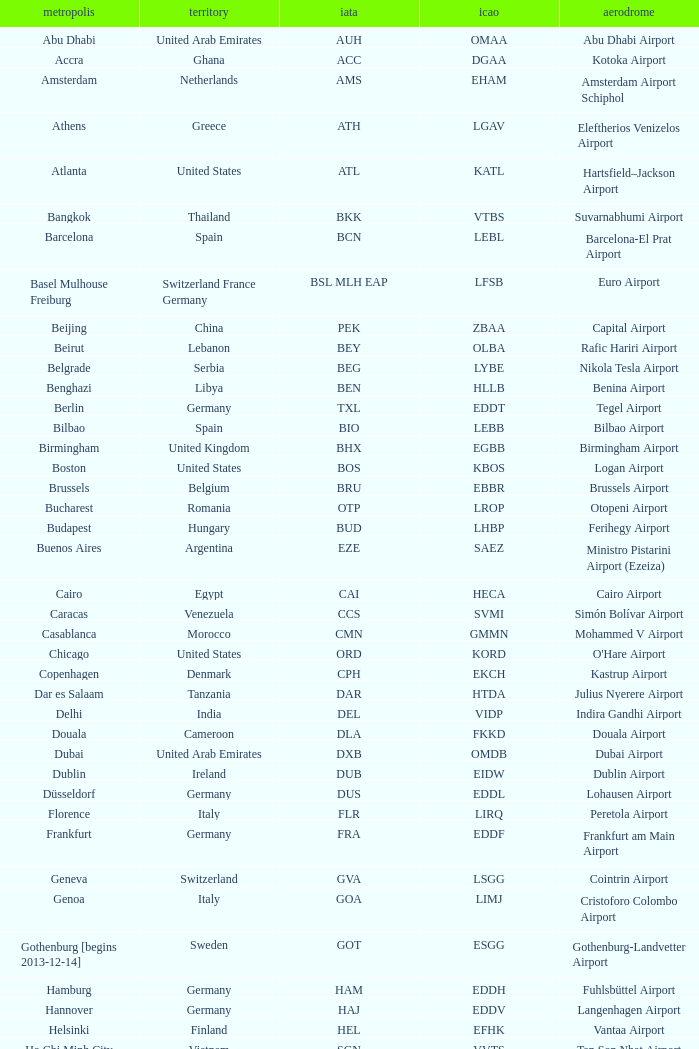Can you parse all the data within this table? {'header': ['metropolis', 'territory', 'iata', 'icao', 'aerodrome'], 'rows': [['Abu Dhabi', 'United Arab Emirates', 'AUH', 'OMAA', 'Abu Dhabi Airport'], ['Accra', 'Ghana', 'ACC', 'DGAA', 'Kotoka Airport'], ['Amsterdam', 'Netherlands', 'AMS', 'EHAM', 'Amsterdam Airport Schiphol'], ['Athens', 'Greece', 'ATH', 'LGAV', 'Eleftherios Venizelos Airport'], ['Atlanta', 'United States', 'ATL', 'KATL', 'Hartsfield–Jackson Airport'], ['Bangkok', 'Thailand', 'BKK', 'VTBS', 'Suvarnabhumi Airport'], ['Barcelona', 'Spain', 'BCN', 'LEBL', 'Barcelona-El Prat Airport'], ['Basel Mulhouse Freiburg', 'Switzerland France Germany', 'BSL MLH EAP', 'LFSB', 'Euro Airport'], ['Beijing', 'China', 'PEK', 'ZBAA', 'Capital Airport'], ['Beirut', 'Lebanon', 'BEY', 'OLBA', 'Rafic Hariri Airport'], ['Belgrade', 'Serbia', 'BEG', 'LYBE', 'Nikola Tesla Airport'], ['Benghazi', 'Libya', 'BEN', 'HLLB', 'Benina Airport'], ['Berlin', 'Germany', 'TXL', 'EDDT', 'Tegel Airport'], ['Bilbao', 'Spain', 'BIO', 'LEBB', 'Bilbao Airport'], ['Birmingham', 'United Kingdom', 'BHX', 'EGBB', 'Birmingham Airport'], ['Boston', 'United States', 'BOS', 'KBOS', 'Logan Airport'], ['Brussels', 'Belgium', 'BRU', 'EBBR', 'Brussels Airport'], ['Bucharest', 'Romania', 'OTP', 'LROP', 'Otopeni Airport'], ['Budapest', 'Hungary', 'BUD', 'LHBP', 'Ferihegy Airport'], ['Buenos Aires', 'Argentina', 'EZE', 'SAEZ', 'Ministro Pistarini Airport (Ezeiza)'], ['Cairo', 'Egypt', 'CAI', 'HECA', 'Cairo Airport'], ['Caracas', 'Venezuela', 'CCS', 'SVMI', 'Simón Bolívar Airport'], ['Casablanca', 'Morocco', 'CMN', 'GMMN', 'Mohammed V Airport'], ['Chicago', 'United States', 'ORD', 'KORD', "O'Hare Airport"], ['Copenhagen', 'Denmark', 'CPH', 'EKCH', 'Kastrup Airport'], ['Dar es Salaam', 'Tanzania', 'DAR', 'HTDA', 'Julius Nyerere Airport'], ['Delhi', 'India', 'DEL', 'VIDP', 'Indira Gandhi Airport'], ['Douala', 'Cameroon', 'DLA', 'FKKD', 'Douala Airport'], ['Dubai', 'United Arab Emirates', 'DXB', 'OMDB', 'Dubai Airport'], ['Dublin', 'Ireland', 'DUB', 'EIDW', 'Dublin Airport'], ['Düsseldorf', 'Germany', 'DUS', 'EDDL', 'Lohausen Airport'], ['Florence', 'Italy', 'FLR', 'LIRQ', 'Peretola Airport'], ['Frankfurt', 'Germany', 'FRA', 'EDDF', 'Frankfurt am Main Airport'], ['Geneva', 'Switzerland', 'GVA', 'LSGG', 'Cointrin Airport'], ['Genoa', 'Italy', 'GOA', 'LIMJ', 'Cristoforo Colombo Airport'], ['Gothenburg [begins 2013-12-14]', 'Sweden', 'GOT', 'ESGG', 'Gothenburg-Landvetter Airport'], ['Hamburg', 'Germany', 'HAM', 'EDDH', 'Fuhlsbüttel Airport'], ['Hannover', 'Germany', 'HAJ', 'EDDV', 'Langenhagen Airport'], ['Helsinki', 'Finland', 'HEL', 'EFHK', 'Vantaa Airport'], ['Ho Chi Minh City', 'Vietnam', 'SGN', 'VVTS', 'Tan Son Nhat Airport'], ['Hong Kong', 'Hong Kong', 'HKG', 'VHHH', 'Chek Lap Kok Airport'], ['Istanbul', 'Turkey', 'IST', 'LTBA', 'Atatürk Airport'], ['Jakarta', 'Indonesia', 'CGK', 'WIII', 'Soekarno–Hatta Airport'], ['Jeddah', 'Saudi Arabia', 'JED', 'OEJN', 'King Abdulaziz Airport'], ['Johannesburg', 'South Africa', 'JNB', 'FAJS', 'OR Tambo Airport'], ['Karachi', 'Pakistan', 'KHI', 'OPKC', 'Jinnah Airport'], ['Kiev', 'Ukraine', 'KBP', 'UKBB', 'Boryspil International Airport'], ['Lagos', 'Nigeria', 'LOS', 'DNMM', 'Murtala Muhammed Airport'], ['Libreville', 'Gabon', 'LBV', 'FOOL', "Leon M'ba Airport"], ['Lisbon', 'Portugal', 'LIS', 'LPPT', 'Portela Airport'], ['London', 'United Kingdom', 'LCY', 'EGLC', 'City Airport'], ['London [begins 2013-12-14]', 'United Kingdom', 'LGW', 'EGKK', 'Gatwick Airport'], ['London', 'United Kingdom', 'LHR', 'EGLL', 'Heathrow Airport'], ['Los Angeles', 'United States', 'LAX', 'KLAX', 'Los Angeles International Airport'], ['Lugano', 'Switzerland', 'LUG', 'LSZA', 'Agno Airport'], ['Luxembourg City', 'Luxembourg', 'LUX', 'ELLX', 'Findel Airport'], ['Lyon', 'France', 'LYS', 'LFLL', 'Saint-Exupéry Airport'], ['Madrid', 'Spain', 'MAD', 'LEMD', 'Madrid-Barajas Airport'], ['Malabo', 'Equatorial Guinea', 'SSG', 'FGSL', 'Saint Isabel Airport'], ['Malaga', 'Spain', 'AGP', 'LEMG', 'Málaga-Costa del Sol Airport'], ['Manchester', 'United Kingdom', 'MAN', 'EGCC', 'Ringway Airport'], ['Manila', 'Philippines', 'MNL', 'RPLL', 'Ninoy Aquino Airport'], ['Marrakech [begins 2013-11-01]', 'Morocco', 'RAK', 'GMMX', 'Menara Airport'], ['Miami', 'United States', 'MIA', 'KMIA', 'Miami Airport'], ['Milan', 'Italy', 'MXP', 'LIMC', 'Malpensa Airport'], ['Minneapolis', 'United States', 'MSP', 'KMSP', 'Minneapolis Airport'], ['Montreal', 'Canada', 'YUL', 'CYUL', 'Pierre Elliott Trudeau Airport'], ['Moscow', 'Russia', 'DME', 'UUDD', 'Domodedovo Airport'], ['Mumbai', 'India', 'BOM', 'VABB', 'Chhatrapati Shivaji Airport'], ['Munich', 'Germany', 'MUC', 'EDDM', 'Franz Josef Strauss Airport'], ['Muscat', 'Oman', 'MCT', 'OOMS', 'Seeb Airport'], ['Nairobi', 'Kenya', 'NBO', 'HKJK', 'Jomo Kenyatta Airport'], ['Newark', 'United States', 'EWR', 'KEWR', 'Liberty Airport'], ['New York City', 'United States', 'JFK', 'KJFK', 'John F Kennedy Airport'], ['Nice', 'France', 'NCE', 'LFMN', "Côte d'Azur Airport"], ['Nuremberg', 'Germany', 'NUE', 'EDDN', 'Nuremberg Airport'], ['Oslo', 'Norway', 'OSL', 'ENGM', 'Gardermoen Airport'], ['Palma de Mallorca', 'Spain', 'PMI', 'LFPA', 'Palma de Mallorca Airport'], ['Paris', 'France', 'CDG', 'LFPG', 'Charles de Gaulle Airport'], ['Porto', 'Portugal', 'OPO', 'LPPR', 'Francisco de Sa Carneiro Airport'], ['Prague', 'Czech Republic', 'PRG', 'LKPR', 'Ruzyně Airport'], ['Riga', 'Latvia', 'RIX', 'EVRA', 'Riga Airport'], ['Rio de Janeiro [resumes 2014-7-14]', 'Brazil', 'GIG', 'SBGL', 'Galeão Airport'], ['Riyadh', 'Saudi Arabia', 'RUH', 'OERK', 'King Khalid Airport'], ['Rome', 'Italy', 'FCO', 'LIRF', 'Leonardo da Vinci Airport'], ['Saint Petersburg', 'Russia', 'LED', 'ULLI', 'Pulkovo Airport'], ['San Francisco', 'United States', 'SFO', 'KSFO', 'San Francisco Airport'], ['Santiago', 'Chile', 'SCL', 'SCEL', 'Comodoro Arturo Benitez Airport'], ['São Paulo', 'Brazil', 'GRU', 'SBGR', 'Guarulhos Airport'], ['Sarajevo', 'Bosnia and Herzegovina', 'SJJ', 'LQSA', 'Butmir Airport'], ['Seattle', 'United States', 'SEA', 'KSEA', 'Sea-Tac Airport'], ['Shanghai', 'China', 'PVG', 'ZSPD', 'Pudong Airport'], ['Singapore', 'Singapore', 'SIN', 'WSSS', 'Changi Airport'], ['Skopje', 'Republic of Macedonia', 'SKP', 'LWSK', 'Alexander the Great Airport'], ['Sofia', 'Bulgaria', 'SOF', 'LBSF', 'Vrazhdebna Airport'], ['Stockholm', 'Sweden', 'ARN', 'ESSA', 'Arlanda Airport'], ['Stuttgart', 'Germany', 'STR', 'EDDS', 'Echterdingen Airport'], ['Taipei', 'Taiwan', 'TPE', 'RCTP', 'Taoyuan Airport'], ['Tehran', 'Iran', 'IKA', 'OIIE', 'Imam Khomeini Airport'], ['Tel Aviv', 'Israel', 'TLV', 'LLBG', 'Ben Gurion Airport'], ['Thessaloniki', 'Greece', 'SKG', 'LGTS', 'Macedonia Airport'], ['Tirana', 'Albania', 'TIA', 'LATI', 'Nënë Tereza Airport'], ['Tokyo', 'Japan', 'NRT', 'RJAA', 'Narita Airport'], ['Toronto', 'Canada', 'YYZ', 'CYYZ', 'Pearson Airport'], ['Tripoli', 'Libya', 'TIP', 'HLLT', 'Tripoli Airport'], ['Tunis', 'Tunisia', 'TUN', 'DTTA', 'Carthage Airport'], ['Turin', 'Italy', 'TRN', 'LIMF', 'Sandro Pertini Airport'], ['Valencia', 'Spain', 'VLC', 'LEVC', 'Valencia Airport'], ['Venice', 'Italy', 'VCE', 'LIPZ', 'Marco Polo Airport'], ['Vienna', 'Austria', 'VIE', 'LOWW', 'Schwechat Airport'], ['Warsaw', 'Poland', 'WAW', 'EPWA', 'Frederic Chopin Airport'], ['Washington DC', 'United States', 'IAD', 'KIAD', 'Dulles Airport'], ['Yaounde', 'Cameroon', 'NSI', 'FKYS', 'Yaounde Nsimalen Airport'], ['Yerevan', 'Armenia', 'EVN', 'UDYZ', 'Zvartnots Airport'], ['Zurich', 'Switzerland', 'ZRH', 'LSZH', 'Zurich Airport']]} What is the ICAO of Douala city? FKKD. 